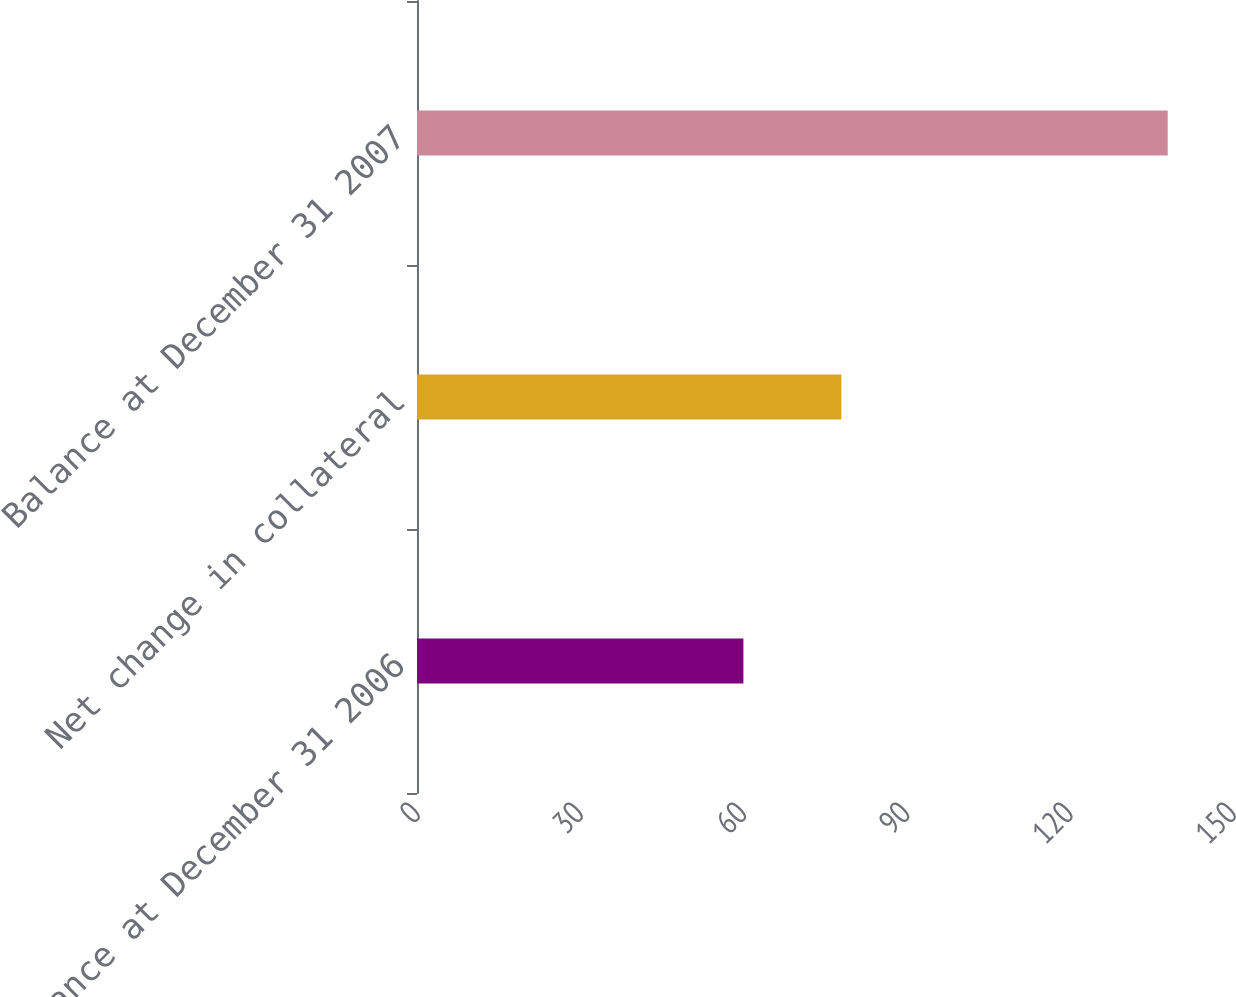Convert chart. <chart><loc_0><loc_0><loc_500><loc_500><bar_chart><fcel>Balance at December 31 2006<fcel>Net change in collateral<fcel>Balance at December 31 2007<nl><fcel>60<fcel>78<fcel>138<nl></chart> 